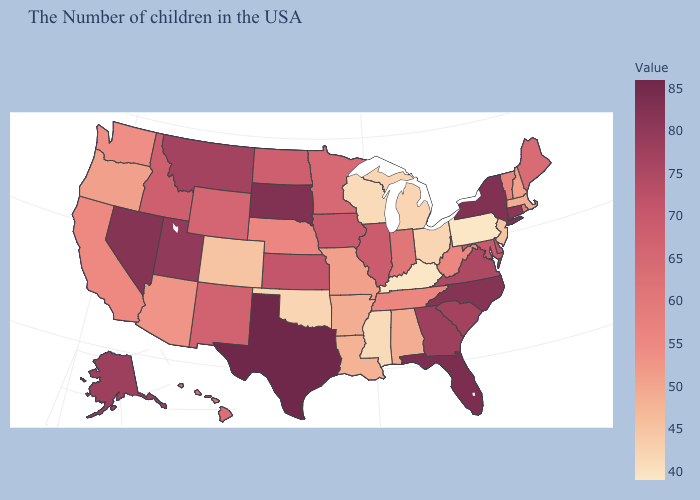Is the legend a continuous bar?
Answer briefly. Yes. Does Hawaii have a lower value than South Carolina?
Answer briefly. Yes. Does Illinois have the lowest value in the USA?
Answer briefly. No. Does Missouri have a higher value than South Dakota?
Quick response, please. No. Among the states that border Wisconsin , which have the lowest value?
Write a very short answer. Michigan. Which states hav the highest value in the West?
Give a very brief answer. Nevada. Does Indiana have the highest value in the USA?
Write a very short answer. No. Among the states that border Colorado , does Utah have the highest value?
Concise answer only. Yes. Does Texas have the highest value in the USA?
Keep it brief. Yes. 